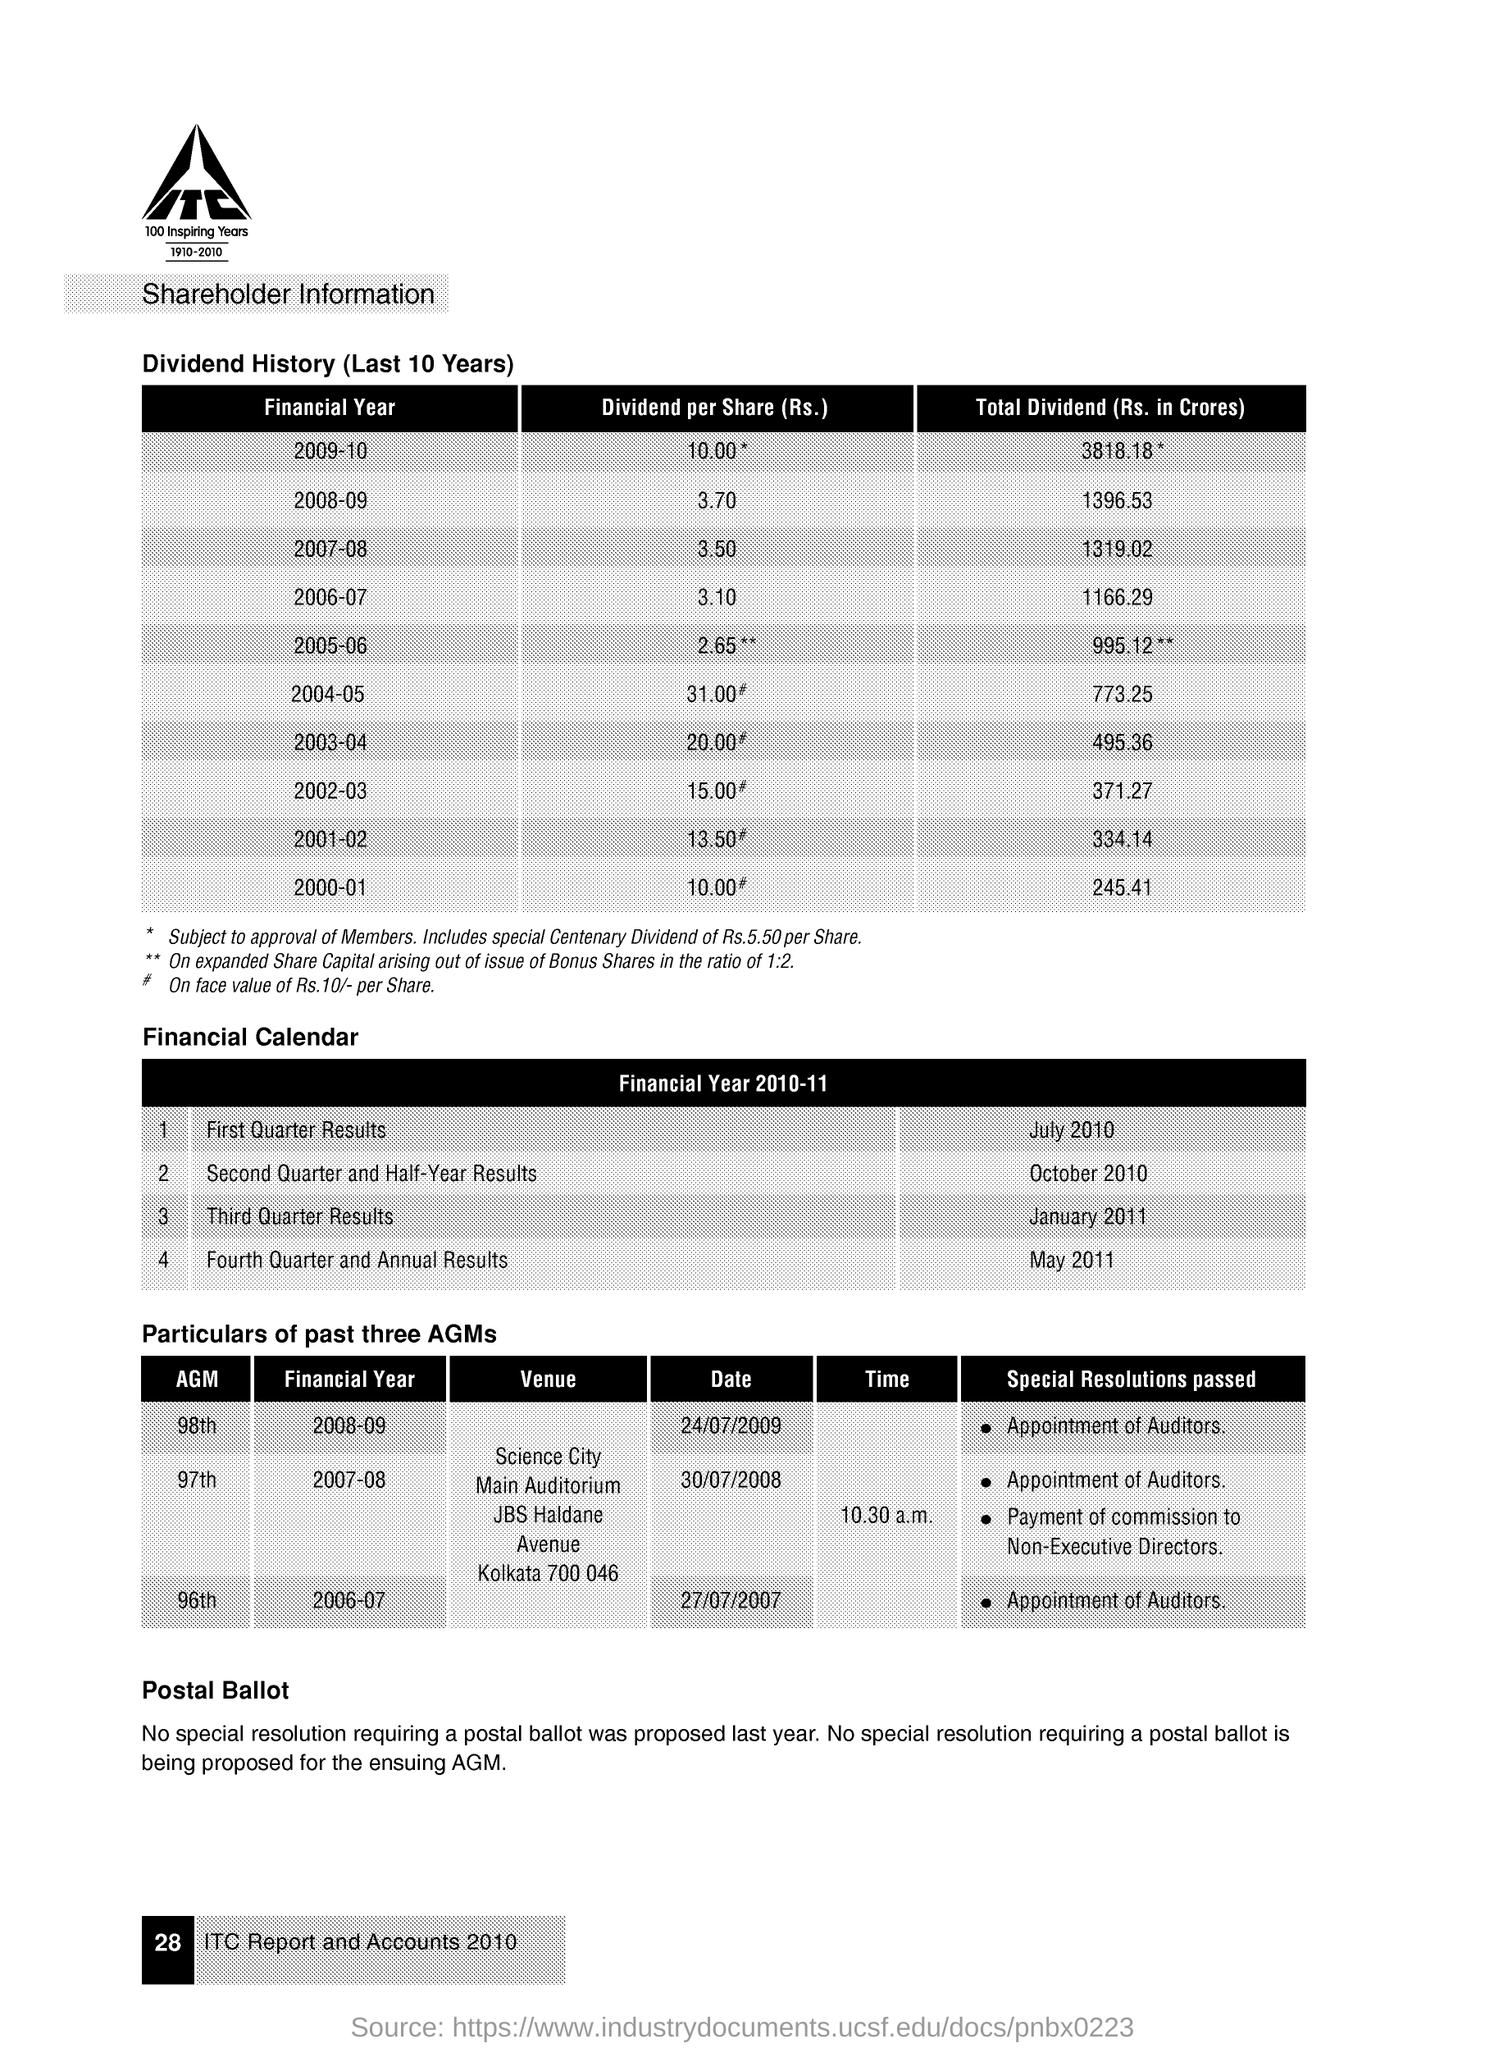Can you tell me about the dividend trends over the last few years according to the image? As per the image, the dividend trend over the last few years shows a fluctuation with some significant spikes. For instance, the Financial Year 2004-05 shows an unusually high Dividend per Share of Rs. 31.00. It appears to be a special case, as the footnote refers to a 'special Centenary Dividend of Rs.5.50 per Share.' Generally, however, there seems to be a gradual increase in the dividend value over the years. 